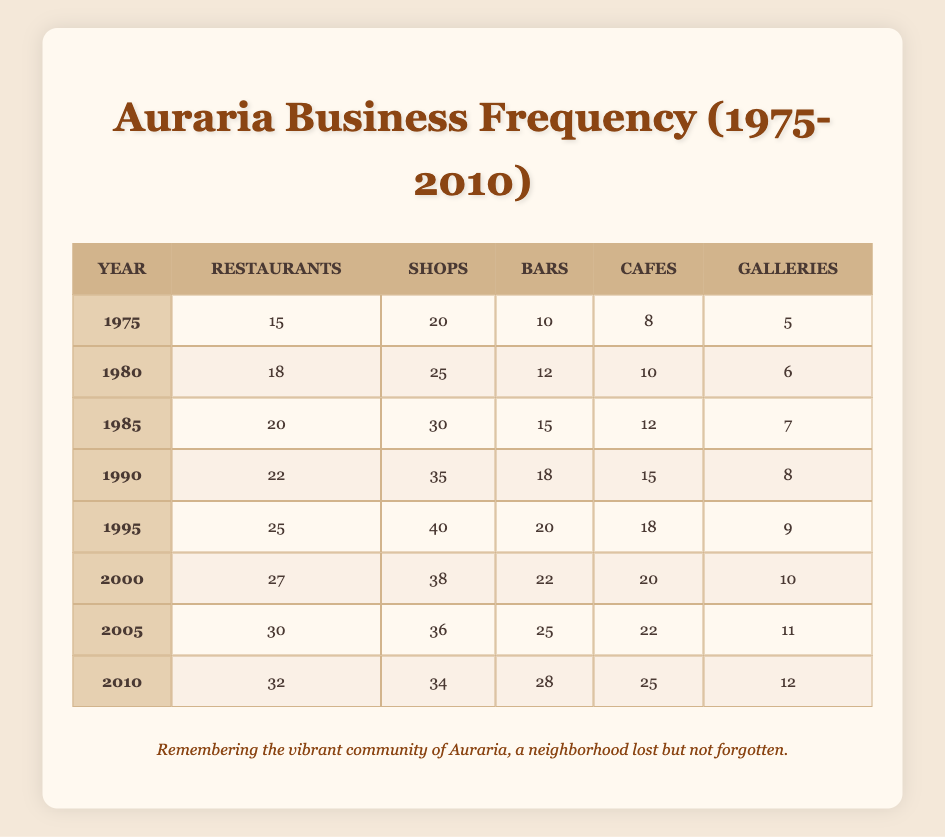What year had the highest number of restaurants? Inspect each year's restaurant count in the table: 1975 (15), 1980 (18), 1985 (20), 1990 (22), 1995 (25), 2000 (27), 2005 (30), 2010 (32). The highest number is in 2010 with 32 restaurants.
Answer: 2010 What was the total number of shops in 1995? The table shows that in 1995 there were 40 shops.
Answer: 40 How many more bars were there in 2005 than in 1980? Check the bar counts for both years: 2005 has 25 bars and 1980 has 12 bars. The difference is 25 - 12 = 13.
Answer: 13 Did the number of galleries increase or decrease between 1985 and 1990? Compare the gallery counts: in 1985 there were 7 galleries and in 1990 there were 8. As the count increased from 7 to 8, the answer is an increase.
Answer: Increase What is the average number of cafes from 1975 to 2010? Calculate the sum of cafes for each year: 8 + 10 + 12 + 15 + 18 + 20 + 22 + 25 = 110. There are 8 data points, so the average is 110 / 8 = 13.75.
Answer: 13.75 Which year saw the least number of galleries? Review the gallery counts: 1975 (5), 1980 (6), 1985 (7), 1990 (8), 1995 (9), 2000 (10), 2005 (11), 2010 (12). The least number of galleries was in 1975 with 5 galleries.
Answer: 1975 How many total businesses (all types) were there in 1990? To find the total, add all categories for 1990: Restaurants (22) + Shops (35) + Bars (18) + Cafes (15) + Galleries (8) = 98.
Answer: 98 Was there a year when the number of restaurants and bars combined exceeded 60? Check the combined totals for each year: for instance, in 2005, Restaurants (30) + Bars (25) = 55; in 2010, Restaurants (32) + Bars (28) = 60; in 2000, Restaurants (27) + Bars (22) = 49. So, the only year that met the condition is 2010, which equals 60, thus yes.
Answer: Yes What was the increase in the number of shops from 1980 to 2010? Shops in 1980 totaled 25 while in 2010 they totaled 34. The increase is 34 - 25 = 9.
Answer: 9 